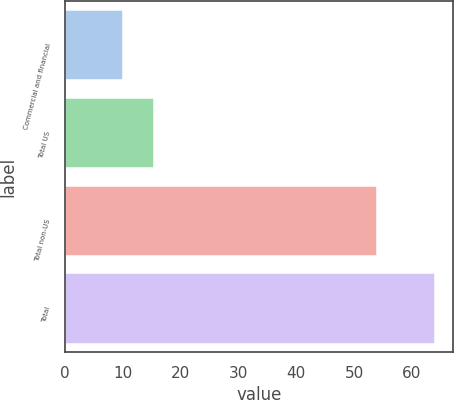Convert chart to OTSL. <chart><loc_0><loc_0><loc_500><loc_500><bar_chart><fcel>Commercial and financial<fcel>Total US<fcel>Total non-US<fcel>Total<nl><fcel>10<fcel>15.4<fcel>54<fcel>64<nl></chart> 